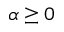<formula> <loc_0><loc_0><loc_500><loc_500>\alpha \geq 0</formula> 